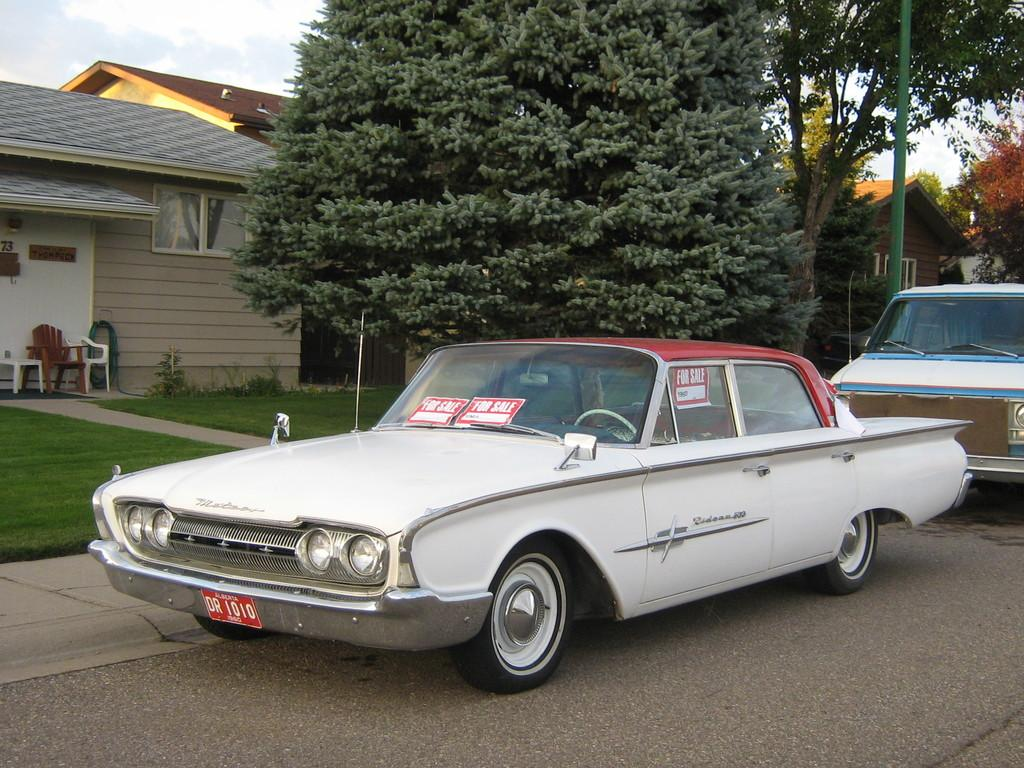What can be seen on the road in the image? There are vehicles on the road in the image. What type of structures can be seen in the background of the image? There are houses in the background of the image. What architectural features are visible on the houses in the background? There are roofs and windows visible on the houses in the background. What type of furniture can be seen in the background of the image? There are chairs in the background of the image. What type of vegetation is present on the ground in the background of the image? Grass and trees are visible on the ground in the background of the image. What type of vertical structures can be seen in the background of the image? There are poles in the background of the image. What is visible in the sky in the background of the image? Clouds are visible in the sky in the background of the image. What type of thread is being used to create the sky in the image? There is no thread present in the image; the sky is depicted using a photographic or artistic representation. What type of range is visible in the background of the image? There is no range present in the image; the background features houses, roofs, windows, chairs, grass, trees, poles, and clouds. 